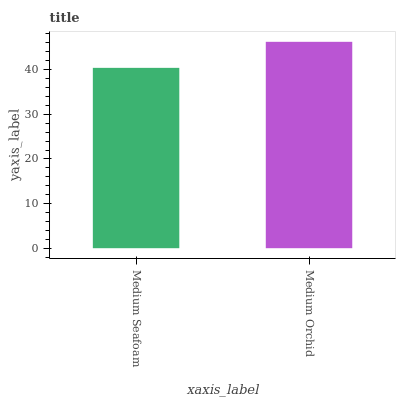Is Medium Seafoam the minimum?
Answer yes or no. Yes. Is Medium Orchid the maximum?
Answer yes or no. Yes. Is Medium Orchid the minimum?
Answer yes or no. No. Is Medium Orchid greater than Medium Seafoam?
Answer yes or no. Yes. Is Medium Seafoam less than Medium Orchid?
Answer yes or no. Yes. Is Medium Seafoam greater than Medium Orchid?
Answer yes or no. No. Is Medium Orchid less than Medium Seafoam?
Answer yes or no. No. Is Medium Orchid the high median?
Answer yes or no. Yes. Is Medium Seafoam the low median?
Answer yes or no. Yes. Is Medium Seafoam the high median?
Answer yes or no. No. Is Medium Orchid the low median?
Answer yes or no. No. 